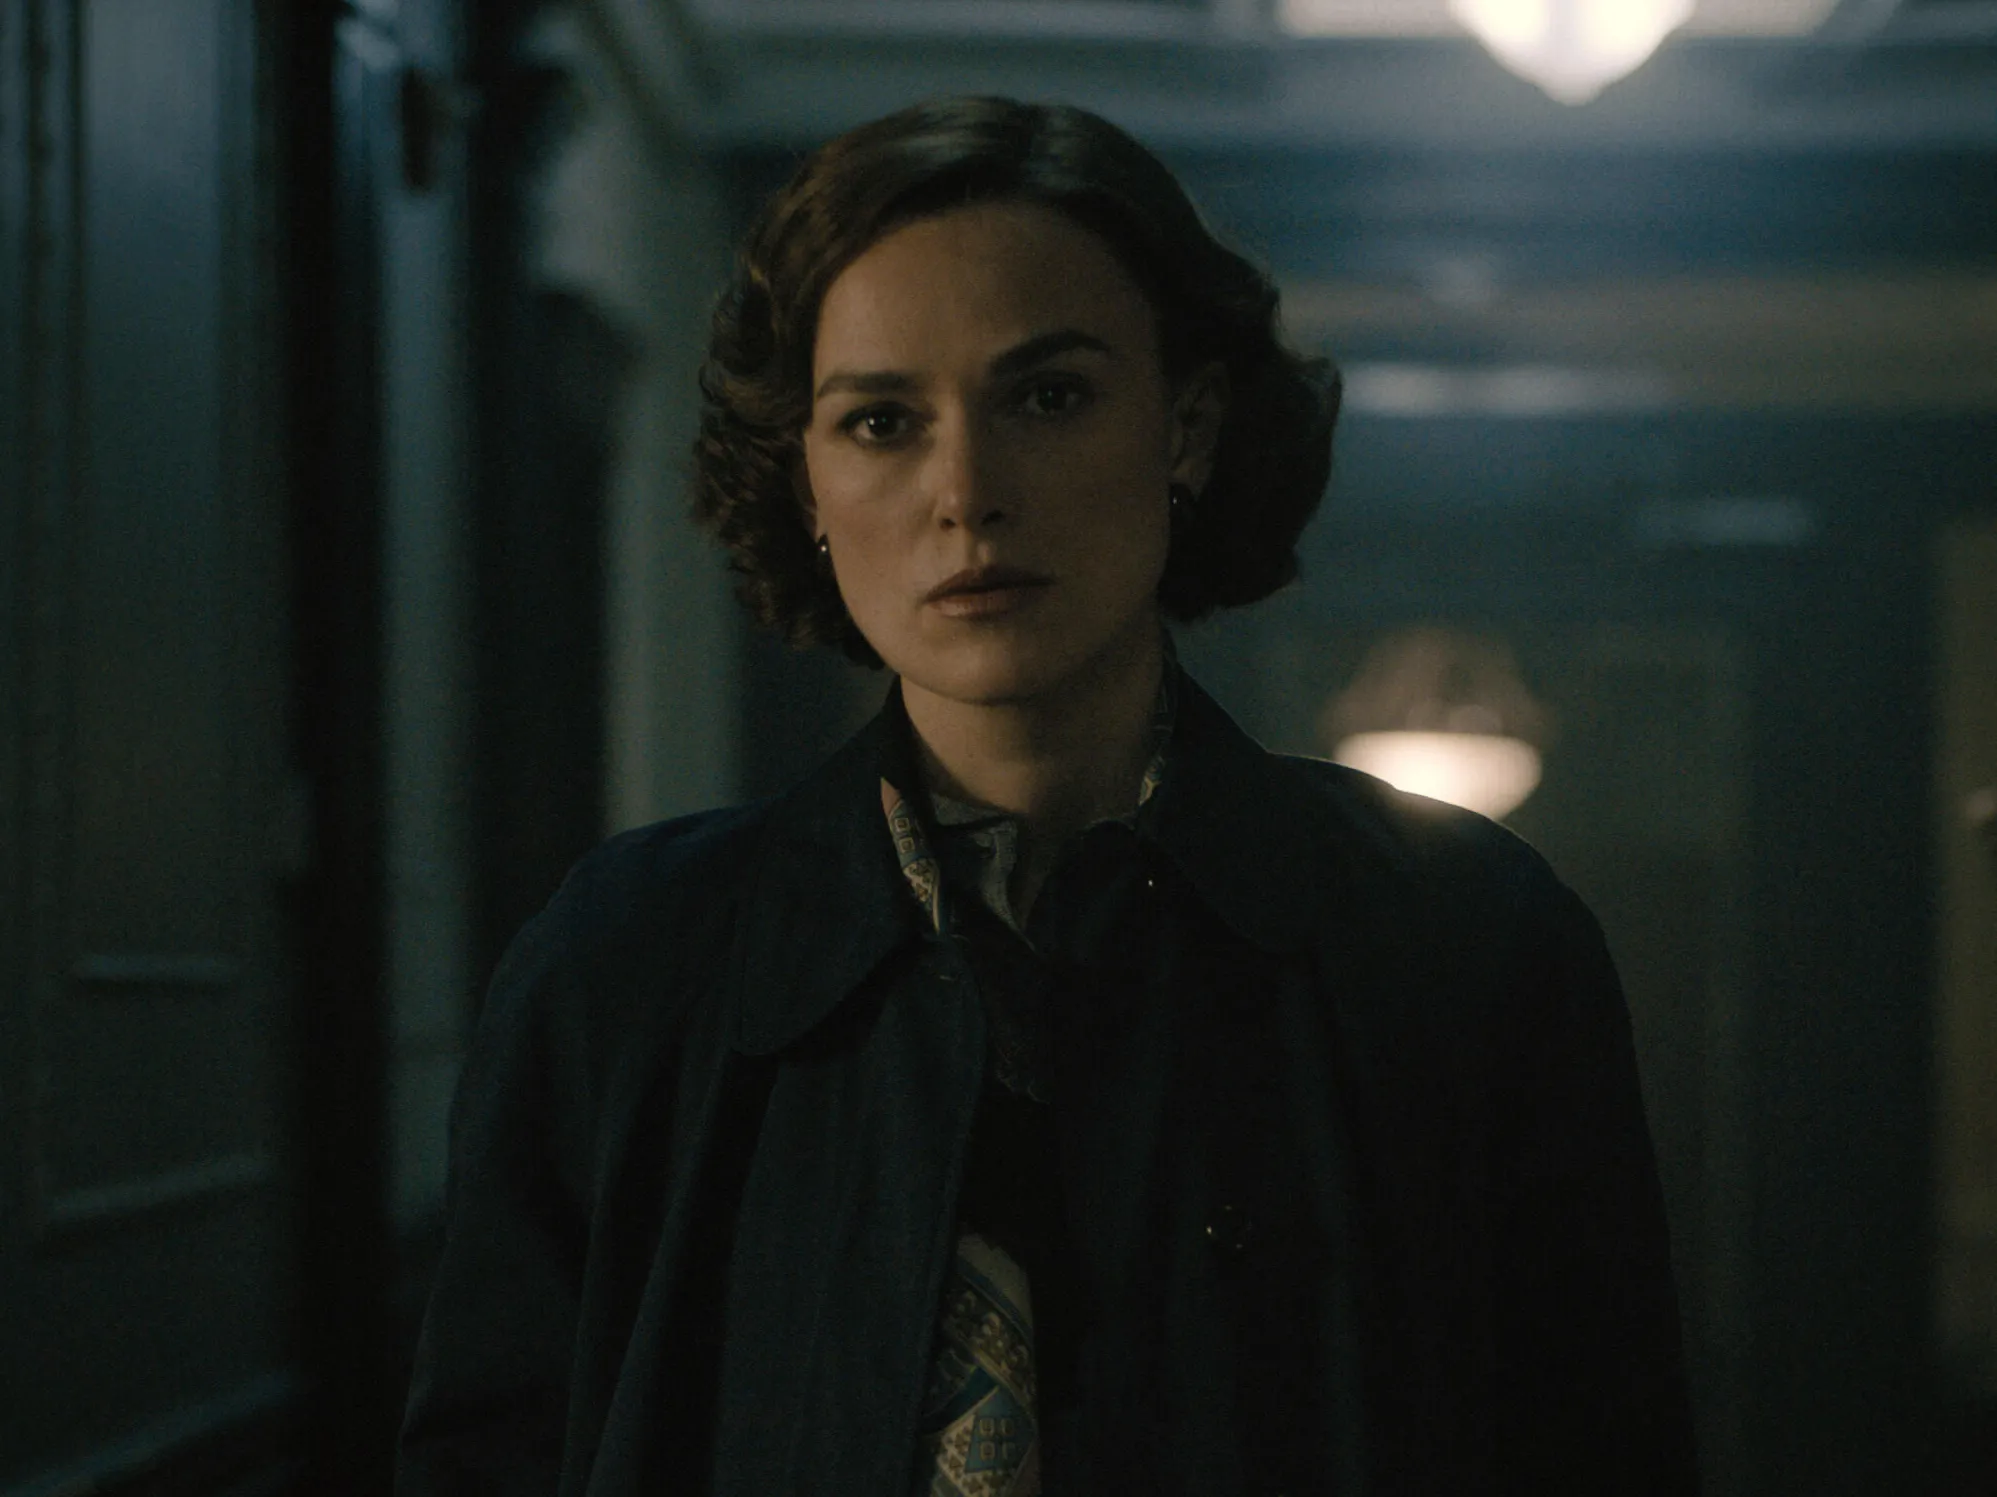Can you describe the details of her outfit? In the image, the woman is wearing a dark blue coat that appears to be made of a warm, heavy material, suitable for cool weather. Underneath, there is a glimpse of a patterned scarf that features intricate designs in muted tones, adding a layer of sophistication to her ensemble. Her style is both chic and classic, with her short bob haircut adding a modern touch to her overall appearance. What do you think this scene might be about? This scene seems to depict a moment of deep contemplation or concern. The setting—a dimly lit hallway with a somewhat somber atmosphere—suggests that the woman might be going through an emotional or pivotal moment. Perhaps she's just received important, life-changing news, or is considering a difficult decision. The overall mood of the image feels intense and dramatic, much like a scene from a suspenseful movie where crucial events are about to unfold. 